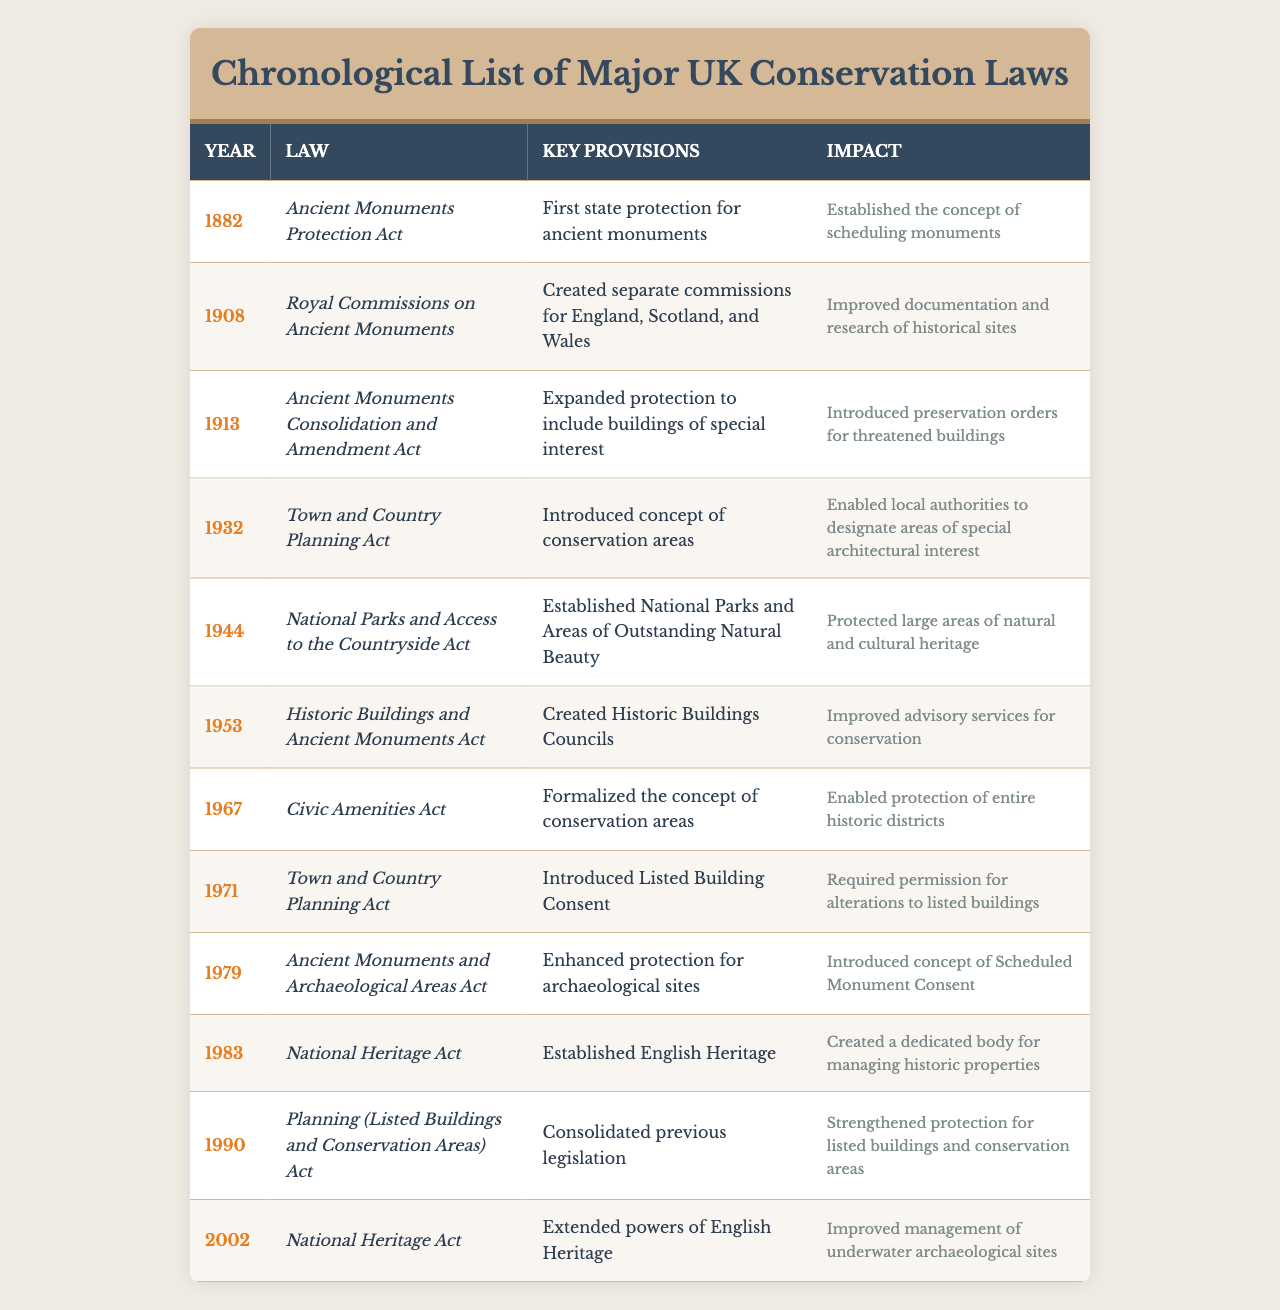What year was the Ancient Monuments Protection Act enacted? The table indicates that the Ancient Monuments Protection Act was enacted in the year 1882.
Answer: 1882 What impact did the Royal Commissions on Ancient Monuments have? According to the table, the impact of the Royal Commissions on Ancient Monuments was to improve documentation and research of historical sites.
Answer: Improved documentation and research of historical sites How many laws were enacted before 1950? By examining the table, the laws enacted before 1950 are from 1882 (Ancient Monuments Protection Act) to 1944 (National Parks and Access to the Countryside Act), totaling 7 laws.
Answer: 7 Did the Town and Country Planning Act introduce the concept of conservation areas? Yes, the table states that the Town and Country Planning Act introduced the concept of conservation areas in 1932.
Answer: Yes Which law was enacted most recently, and what was its impact? The most recent law indicated in the table is the National Heritage Act from 2002, which improved management of underwater archaeological sites.
Answer: National Heritage Act, improved management of underwater archaeological sites What is the total number of laws listed in the table? The table contains 12 different laws, from the Ancient Monuments Protection Act in 1882 to the National Heritage Act in 2002, which is the total count.
Answer: 12 What are the key provisions introduced by the Civic Amenities Act? The Civic Amenities Act formalized the concept of conservation areas, as mentioned in the table.
Answer: Formalized the concept of conservation areas How many laws directly mention protection for buildings? Referring to the table, the laws that mention protection for buildings include the Ancient Monuments Protection Act, Ancient Monuments Consolidation and Amendment Act, Historic Buildings and Ancient Monuments Act, and Town and Country Planning Act (1971). This totals to 4 laws.
Answer: 4 Which law established English Heritage? The table specifies that the National Heritage Act of 1983 established English Heritage.
Answer: National Heritage Act (1983) What is the impact of the Town and Country Planning Act from 1932? The table notes that the impact of the 1932 Town and Country Planning Act was that it enabled local authorities to designate areas of special architectural interest.
Answer: Enabled local authorities to designate areas of special architectural interest Are there any laws that focus specifically on archaeological sites? Yes, the Ancient Monuments and Archaeological Areas Act of 1979 enhanced protection for archaeological sites, according to the table.
Answer: Yes 